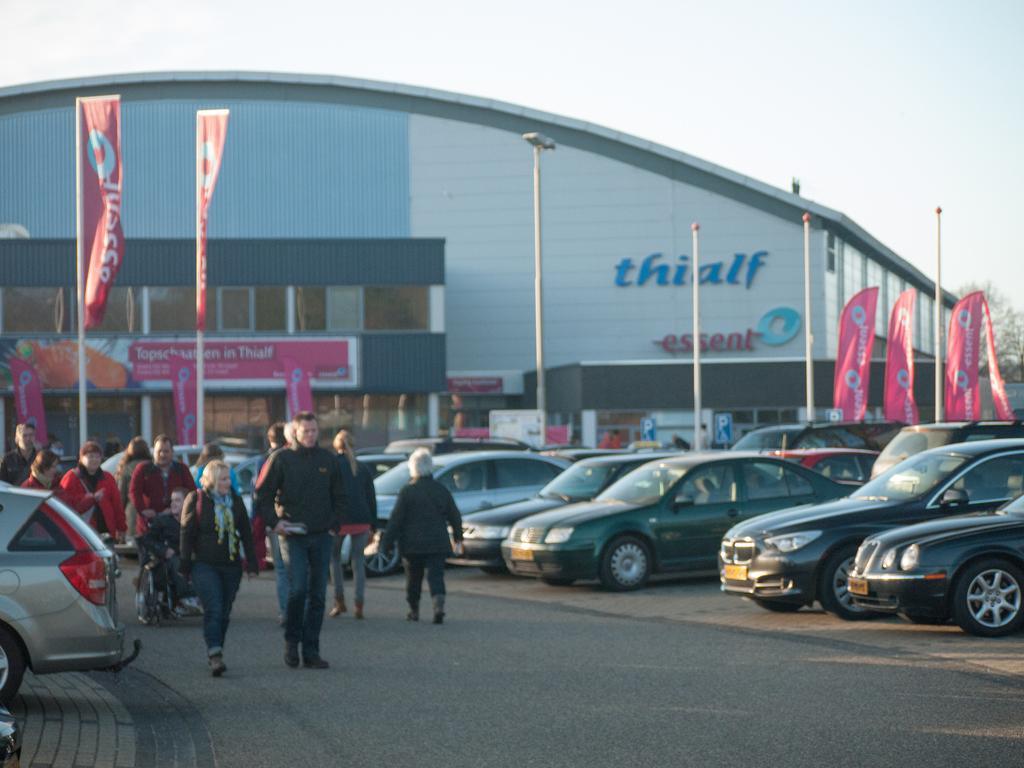Please provide a concise description of this image. This picture shows a building and we see cars parked and few people walking on the road and a tree and we see a cloudy sky. 